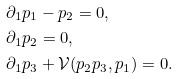<formula> <loc_0><loc_0><loc_500><loc_500>& \partial _ { 1 } p _ { 1 } - p _ { 2 } = 0 , \\ & \partial _ { 1 } p _ { 2 } = 0 , \\ & \partial _ { 1 } p _ { 3 } + \mathcal { V } ( p _ { 2 } p _ { 3 } , p _ { 1 } ) = 0 .</formula> 